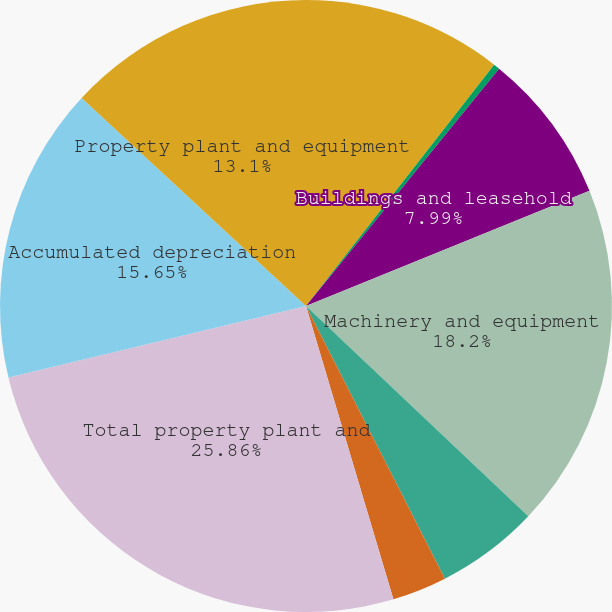<chart> <loc_0><loc_0><loc_500><loc_500><pie_chart><fcel>as of December 31 (in<fcel>Land<fcel>Buildings and leasehold<fcel>Machinery and equipment<fcel>Equipment with customers<fcel>Construction in progress<fcel>Total property plant and<fcel>Accumulated depreciation<fcel>Property plant and equipment<nl><fcel>10.54%<fcel>0.33%<fcel>7.99%<fcel>18.2%<fcel>5.44%<fcel>2.89%<fcel>25.86%<fcel>15.65%<fcel>13.1%<nl></chart> 